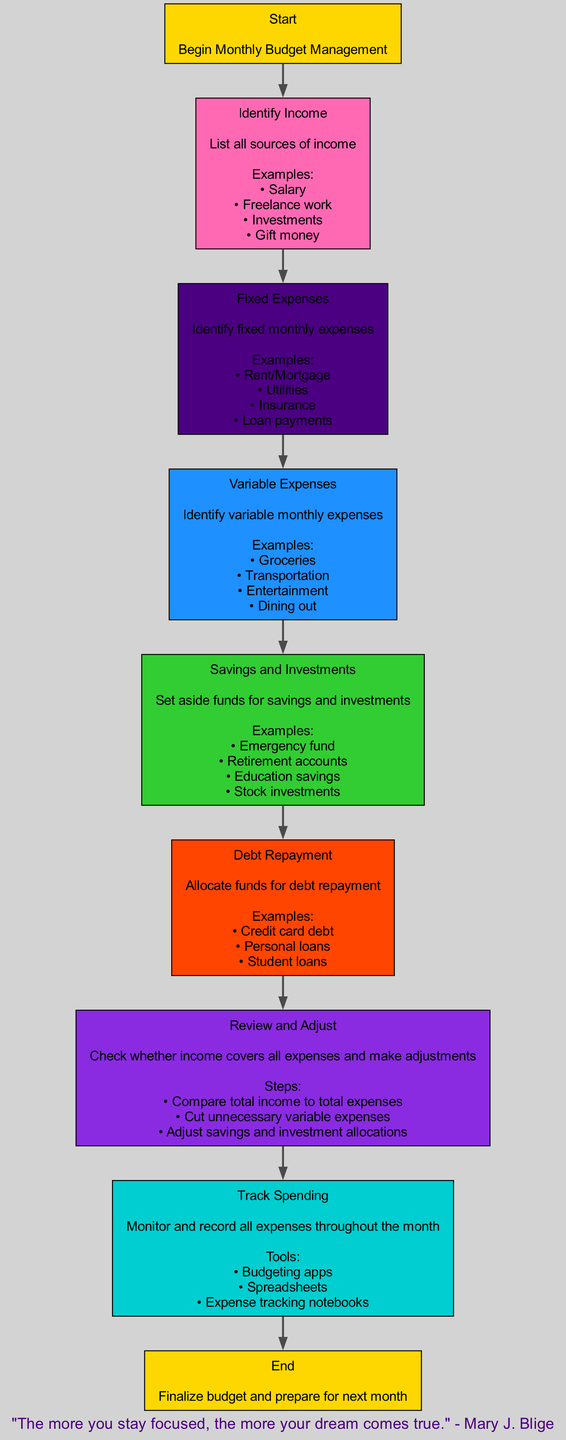What is the first step in the monthly budget management process? The flowchart begins with the "Start" node, which indicates that the first step is to "Begin Monthly Budget Management."
Answer: Begin Monthly Budget Management How many fixed expenses are listed in the diagram? The "Fixed Expenses" node indicates a list of fixed monthly expenses, which include four examples: Rent/Mortgage, Utilities, Insurance, and Loan payments, totaling four items.
Answer: Four What must be done after identifying income and before tracking spending? After "Identify Income," the next step according to the flow is "Track Spending," indicating that funds allocation happens between these two stages.
Answer: Allocate funds What are examples of variable expenses mentioned in the flowchart? The "Variable Expenses" node lists examples such as Groceries, Transportation, Entertainment, and Dining out—all represented under that category.
Answer: Groceries, Transportation, Entertainment, Dining out Which two categories involve allocating funds for specific purposes? The flowchart specifies that "Savings and Investments" and "Debt Repayment" both involve the allocation of funds for their respective purposes.
Answer: Savings and Investments, Debt Repayment What should be checked during the "Review and Adjust" step? The "Review and Adjust" node points out checking if total income covers all expenses, thus indicating that a comparison needs to be made between income and expenses.
Answer: Whether income covers all expenses What tool can be used for tracking spending? The "Track Spending" node mentions several tools that can be used, including budgeting apps, spreadsheets, and expense tracking notebooks.
Answer: Budgeting apps How does the flowchart end? The flowchart concludes with the "End" node, which states, "Finalize budget and prepare for next month." Thus marking the completion of the process.
Answer: Finalize budget and prepare for next month What is the main action in the "Savings and Investments" step? The purpose of the "Savings and Investments" node is to set aside funds specifically for realizing savings and future investments.
Answer: Set aside funds What is the purpose of the "Identify Income" step in the process? The "Identify Income" node focuses on listing all sources of income to have a complete picture before budgeting can begin.
Answer: List all sources of income 